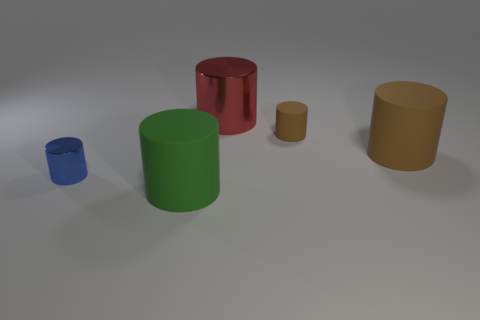The large rubber thing that is the same color as the tiny rubber cylinder is what shape?
Give a very brief answer. Cylinder. Is there a red metal object?
Your answer should be compact. Yes. Are there any other things that have the same shape as the big red thing?
Your answer should be compact. Yes. Are there more brown cylinders in front of the large shiny cylinder than big red objects?
Make the answer very short. Yes. There is a large brown cylinder; are there any big brown objects on the left side of it?
Your answer should be very brief. No. Is the size of the blue metallic object the same as the green rubber thing?
Offer a very short reply. No. What is the size of the blue object that is the same shape as the green matte object?
Offer a terse response. Small. There is a large cylinder in front of the large thing that is right of the large metallic cylinder; what is it made of?
Provide a succinct answer. Rubber. What number of cylinders are behind the green matte object and right of the blue metal cylinder?
Provide a short and direct response. 3. Are there the same number of rubber cylinders that are behind the big green object and big green rubber objects that are behind the blue cylinder?
Give a very brief answer. No. 